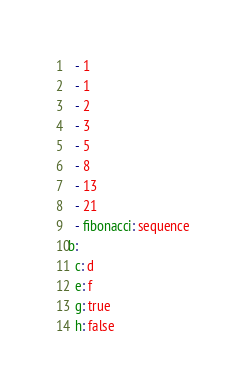Convert code to text. <code><loc_0><loc_0><loc_500><loc_500><_YAML_>  - 1
  - 1
  - 2
  - 3
  - 5
  - 8
  - 13
  - 21
  - fibonacci: sequence
b:
  c: d
  e: f
  g: true
  h: false
</code> 